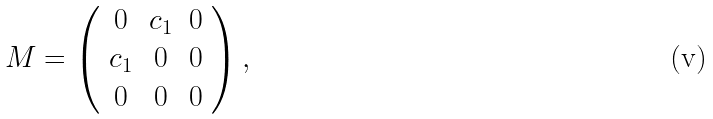Convert formula to latex. <formula><loc_0><loc_0><loc_500><loc_500>M = \left ( \begin{array} { c c c } 0 & c _ { 1 } & 0 \\ c _ { 1 } & 0 & 0 \\ 0 & 0 & 0 \end{array} \right ) ,</formula> 